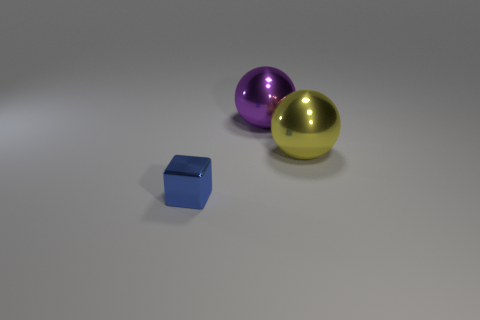How big is the metallic cube in front of the big ball left of the yellow ball?
Make the answer very short. Small. Is the number of big purple shiny balls in front of the large purple metal ball the same as the number of big metal objects on the left side of the big yellow metallic ball?
Ensure brevity in your answer.  No. There is a metallic ball that is behind the yellow metallic ball; are there any small blue objects that are to the left of it?
Your answer should be very brief. Yes. What number of small blue things are in front of the metal object that is to the right of the big sphere that is behind the large yellow shiny sphere?
Make the answer very short. 1. Are there fewer balls than metallic objects?
Offer a very short reply. Yes. There is a shiny thing that is right of the purple object; is its shape the same as the shiny thing that is behind the yellow thing?
Make the answer very short. Yes. What color is the small cube?
Keep it short and to the point. Blue. What number of matte objects are purple cylinders or small blue cubes?
Offer a terse response. 0. What color is the other shiny thing that is the same shape as the yellow metal object?
Provide a short and direct response. Purple. Are any small purple rubber things visible?
Make the answer very short. No. 